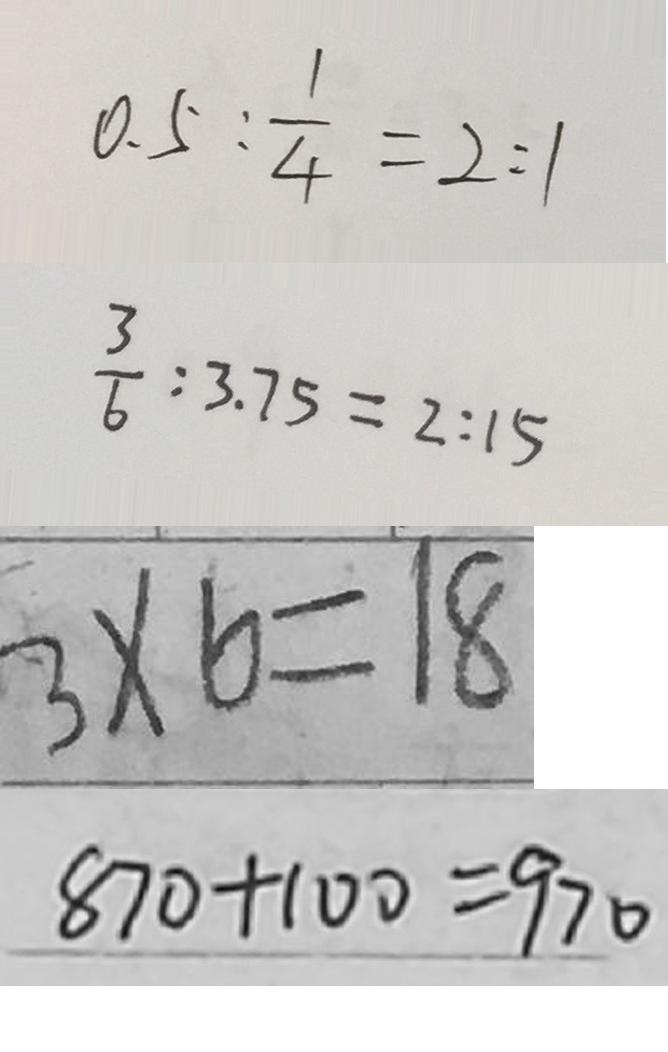Convert formula to latex. <formula><loc_0><loc_0><loc_500><loc_500>0 . 5 : \frac { 1 } { 4 } = 2 : 1 
 \frac { 3 } { 6 } : 3 . 7 5 = 2 : 1 5 
 3 \times 6 = 1 8 
 8 7 0 + 1 0 0 = 9 7 0</formula> 